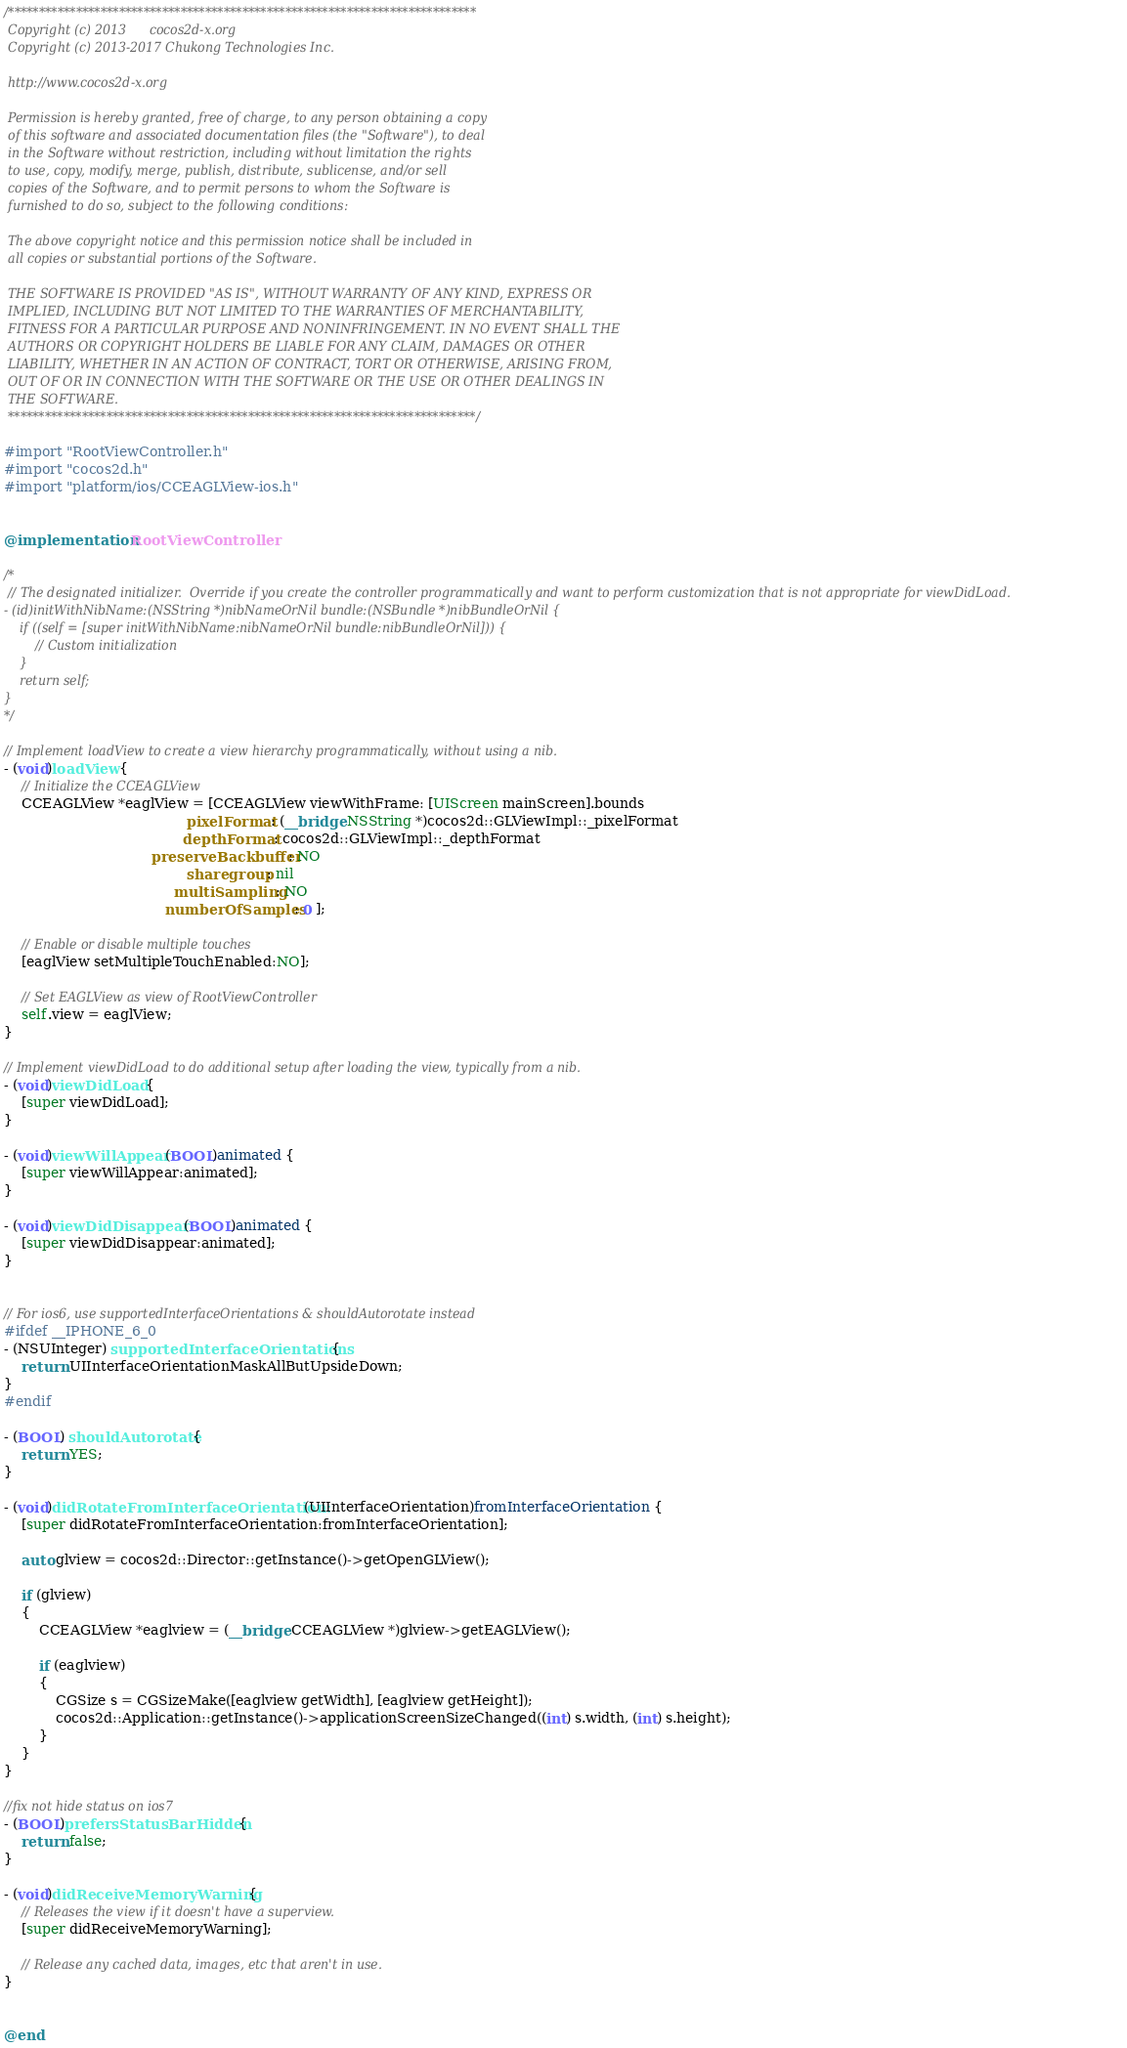Convert code to text. <code><loc_0><loc_0><loc_500><loc_500><_ObjectiveC_>/****************************************************************************
 Copyright (c) 2013      cocos2d-x.org
 Copyright (c) 2013-2017 Chukong Technologies Inc.

 http://www.cocos2d-x.org

 Permission is hereby granted, free of charge, to any person obtaining a copy
 of this software and associated documentation files (the "Software"), to deal
 in the Software without restriction, including without limitation the rights
 to use, copy, modify, merge, publish, distribute, sublicense, and/or sell
 copies of the Software, and to permit persons to whom the Software is
 furnished to do so, subject to the following conditions:

 The above copyright notice and this permission notice shall be included in
 all copies or substantial portions of the Software.

 THE SOFTWARE IS PROVIDED "AS IS", WITHOUT WARRANTY OF ANY KIND, EXPRESS OR
 IMPLIED, INCLUDING BUT NOT LIMITED TO THE WARRANTIES OF MERCHANTABILITY,
 FITNESS FOR A PARTICULAR PURPOSE AND NONINFRINGEMENT. IN NO EVENT SHALL THE
 AUTHORS OR COPYRIGHT HOLDERS BE LIABLE FOR ANY CLAIM, DAMAGES OR OTHER
 LIABILITY, WHETHER IN AN ACTION OF CONTRACT, TORT OR OTHERWISE, ARISING FROM,
 OUT OF OR IN CONNECTION WITH THE SOFTWARE OR THE USE OR OTHER DEALINGS IN
 THE SOFTWARE.
 ****************************************************************************/

#import "RootViewController.h"
#import "cocos2d.h"
#import "platform/ios/CCEAGLView-ios.h"


@implementation RootViewController

/*
 // The designated initializer.  Override if you create the controller programmatically and want to perform customization that is not appropriate for viewDidLoad.
- (id)initWithNibName:(NSString *)nibNameOrNil bundle:(NSBundle *)nibBundleOrNil {
    if ((self = [super initWithNibName:nibNameOrNil bundle:nibBundleOrNil])) {
        // Custom initialization
    }
    return self;
}
*/

// Implement loadView to create a view hierarchy programmatically, without using a nib.
- (void)loadView {
    // Initialize the CCEAGLView
    CCEAGLView *eaglView = [CCEAGLView viewWithFrame: [UIScreen mainScreen].bounds
                                          pixelFormat: (__bridge NSString *)cocos2d::GLViewImpl::_pixelFormat
                                         depthFormat: cocos2d::GLViewImpl::_depthFormat
                                  preserveBackbuffer: NO
                                          sharegroup: nil
                                       multiSampling: NO
                                     numberOfSamples: 0 ];
    
    // Enable or disable multiple touches
    [eaglView setMultipleTouchEnabled:NO];
    
    // Set EAGLView as view of RootViewController
    self.view = eaglView;
}

// Implement viewDidLoad to do additional setup after loading the view, typically from a nib.
- (void)viewDidLoad {
    [super viewDidLoad];
}

- (void)viewWillAppear:(BOOL)animated {
    [super viewWillAppear:animated];
}

- (void)viewDidDisappear:(BOOL)animated {
    [super viewDidDisappear:animated];
}


// For ios6, use supportedInterfaceOrientations & shouldAutorotate instead
#ifdef __IPHONE_6_0
- (NSUInteger) supportedInterfaceOrientations{
    return UIInterfaceOrientationMaskAllButUpsideDown;
}
#endif

- (BOOL) shouldAutorotate {
    return YES;
}

- (void)didRotateFromInterfaceOrientation:(UIInterfaceOrientation)fromInterfaceOrientation {
    [super didRotateFromInterfaceOrientation:fromInterfaceOrientation];

    auto glview = cocos2d::Director::getInstance()->getOpenGLView();

    if (glview)
    {
        CCEAGLView *eaglview = (__bridge CCEAGLView *)glview->getEAGLView();

        if (eaglview)
        {
            CGSize s = CGSizeMake([eaglview getWidth], [eaglview getHeight]);
            cocos2d::Application::getInstance()->applicationScreenSizeChanged((int) s.width, (int) s.height);
        }
    }
}

//fix not hide status on ios7
- (BOOL)prefersStatusBarHidden {
    return false;
}

- (void)didReceiveMemoryWarning {
    // Releases the view if it doesn't have a superview.
    [super didReceiveMemoryWarning];

    // Release any cached data, images, etc that aren't in use.
}


@end
</code> 